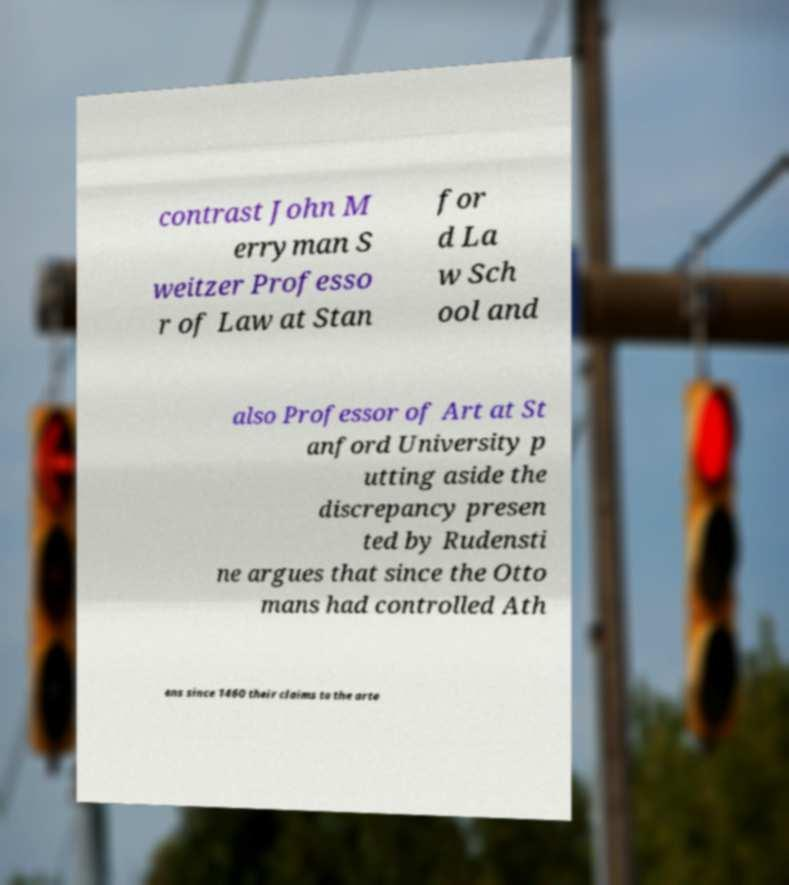There's text embedded in this image that I need extracted. Can you transcribe it verbatim? contrast John M erryman S weitzer Professo r of Law at Stan for d La w Sch ool and also Professor of Art at St anford University p utting aside the discrepancy presen ted by Rudensti ne argues that since the Otto mans had controlled Ath ens since 1460 their claims to the arte 